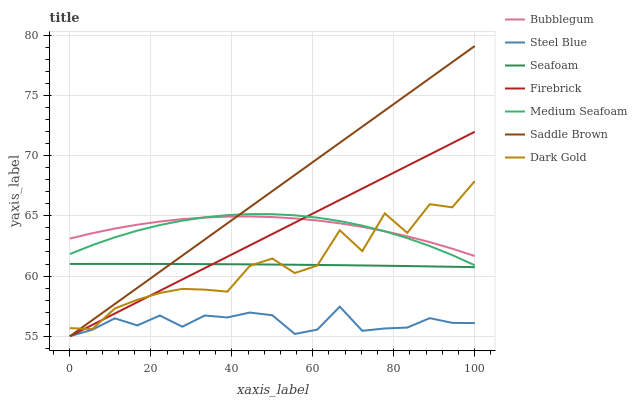Does Steel Blue have the minimum area under the curve?
Answer yes or no. Yes. Does Saddle Brown have the maximum area under the curve?
Answer yes or no. Yes. Does Dark Gold have the minimum area under the curve?
Answer yes or no. No. Does Dark Gold have the maximum area under the curve?
Answer yes or no. No. Is Firebrick the smoothest?
Answer yes or no. Yes. Is Dark Gold the roughest?
Answer yes or no. Yes. Is Dark Gold the smoothest?
Answer yes or no. No. Is Firebrick the roughest?
Answer yes or no. No. Does Firebrick have the lowest value?
Answer yes or no. Yes. Does Dark Gold have the lowest value?
Answer yes or no. No. Does Saddle Brown have the highest value?
Answer yes or no. Yes. Does Dark Gold have the highest value?
Answer yes or no. No. Is Seafoam less than Medium Seafoam?
Answer yes or no. Yes. Is Bubblegum greater than Seafoam?
Answer yes or no. Yes. Does Seafoam intersect Saddle Brown?
Answer yes or no. Yes. Is Seafoam less than Saddle Brown?
Answer yes or no. No. Is Seafoam greater than Saddle Brown?
Answer yes or no. No. Does Seafoam intersect Medium Seafoam?
Answer yes or no. No. 